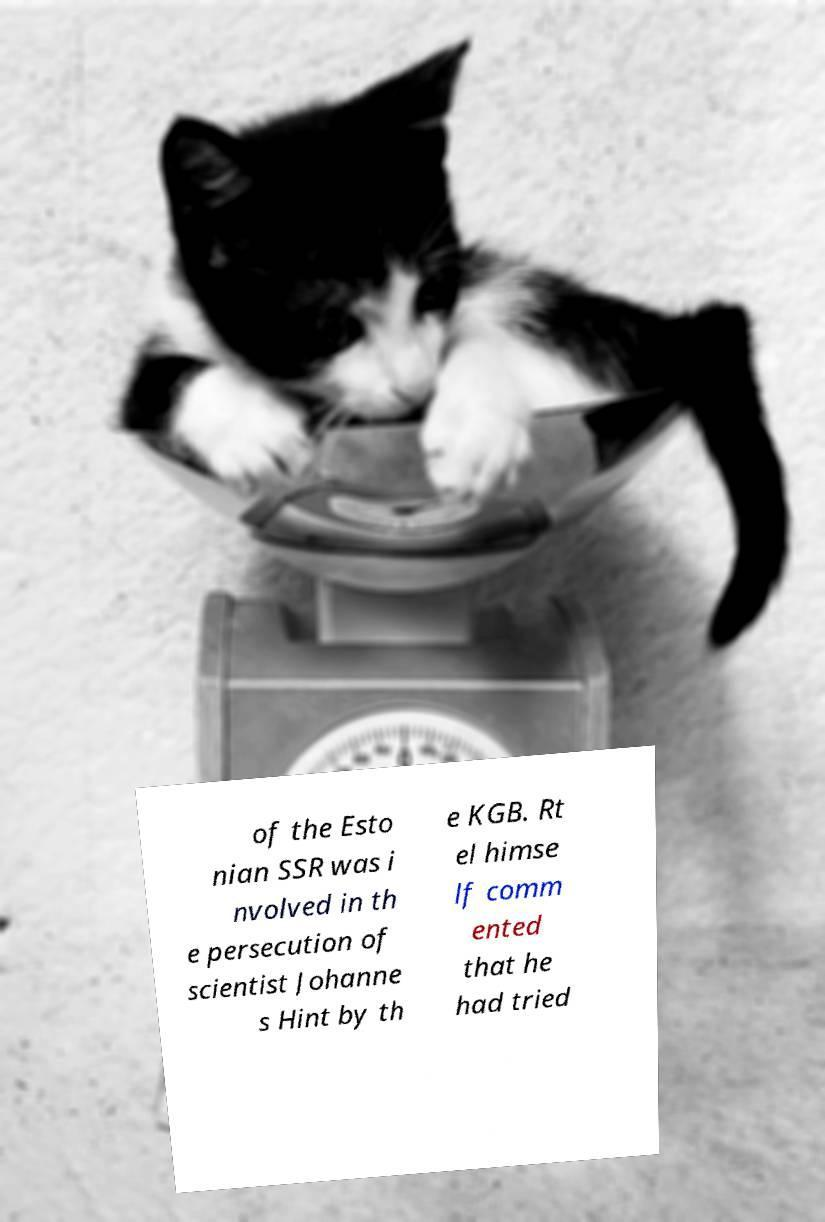Can you read and provide the text displayed in the image?This photo seems to have some interesting text. Can you extract and type it out for me? of the Esto nian SSR was i nvolved in th e persecution of scientist Johanne s Hint by th e KGB. Rt el himse lf comm ented that he had tried 